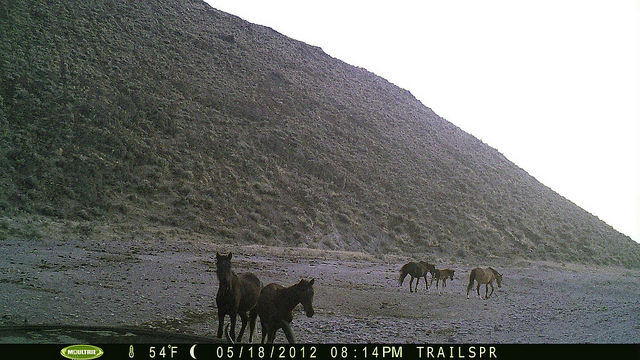<image>Why might the horse be in danger of falling? It is uncertain why the horse might be in danger of falling. It could be due to rocks or uneven terrain. Why might the horse be in danger of falling? I am not sure why the horse might be in danger of falling. It could be because of the rocky terrain or tripping on rocks. 